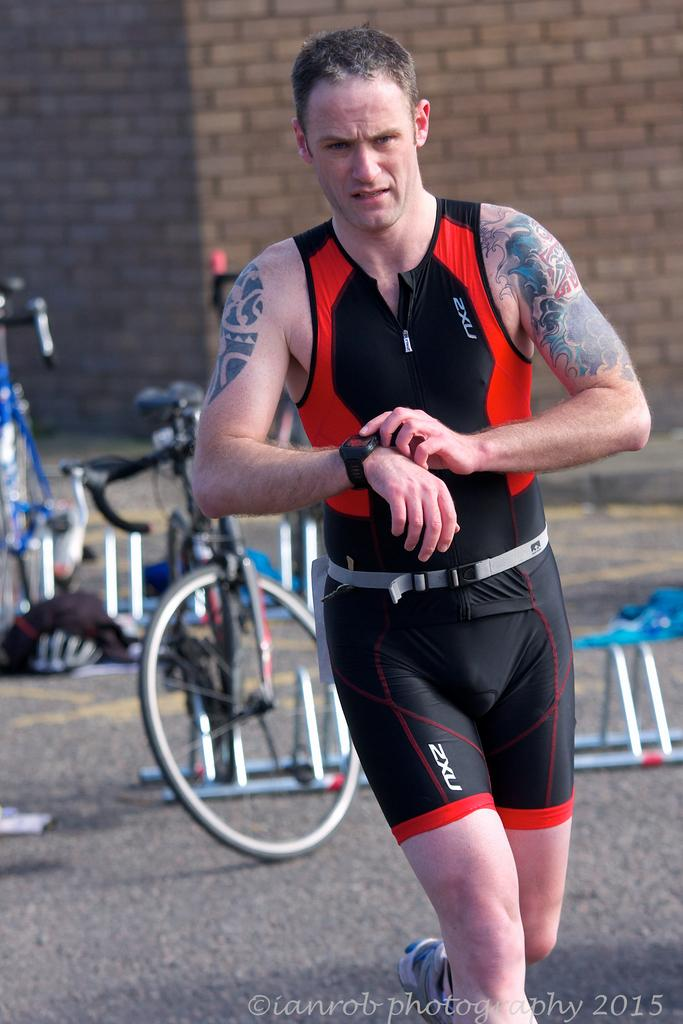What is the man in the image doing? The man is walking in the image. What can be seen near the man? There are bicycles parked in the image. What type of structure is present in the image? There are metal stands in the image. What is visible in the background of the image? There is a wall in the background of the image. Where can text be found in the image? Text is located at the bottom right corner of the image. Can you tell me how many friends the man's grandmother has in the image? There is no mention of a grandmother or friends in the image; it only features a man walking, bicycles, metal stands, a wall, and text. 